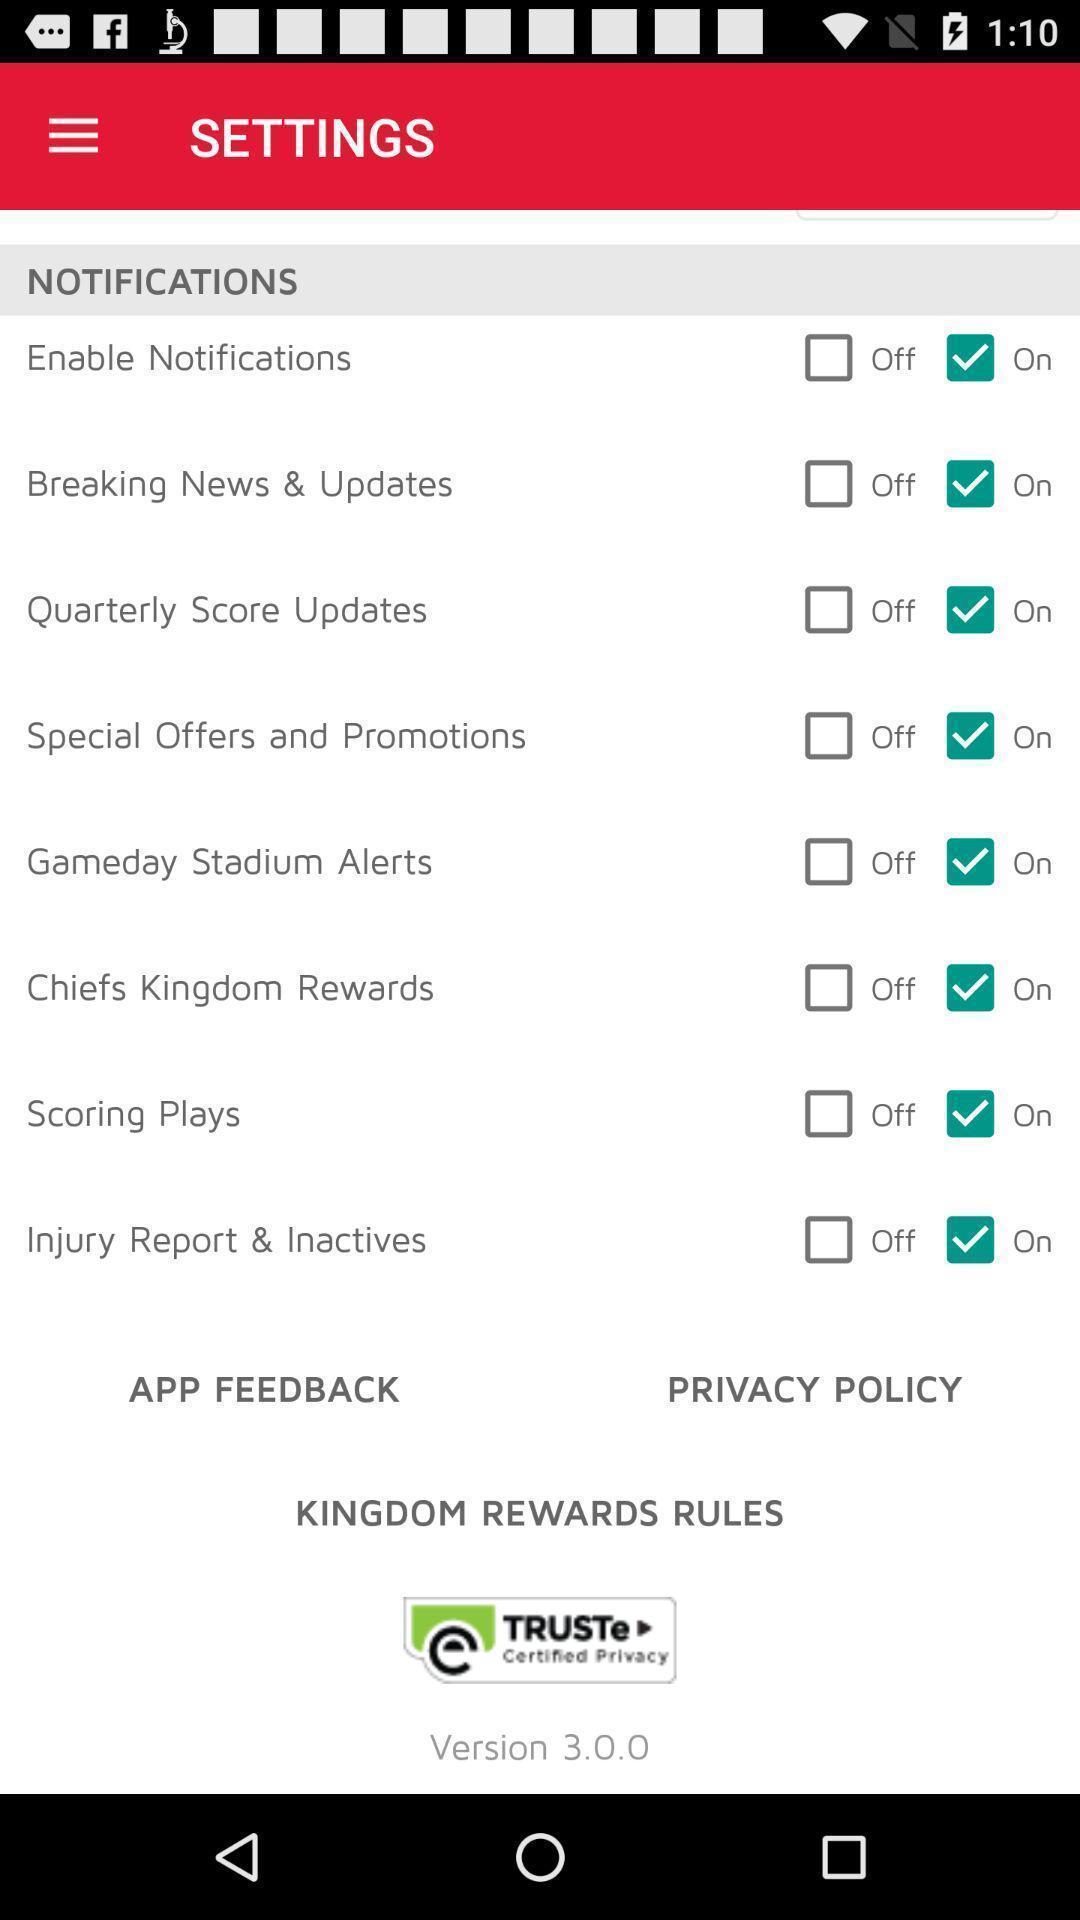Provide a textual representation of this image. Screen showing settings page. 